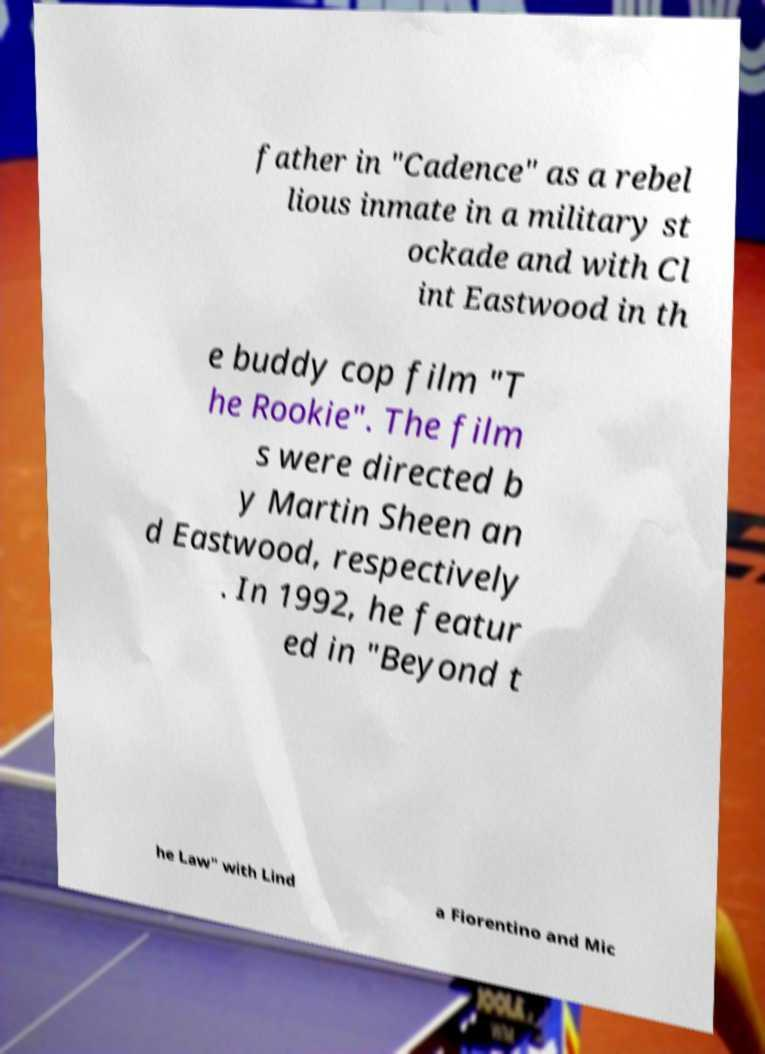Could you assist in decoding the text presented in this image and type it out clearly? father in "Cadence" as a rebel lious inmate in a military st ockade and with Cl int Eastwood in th e buddy cop film "T he Rookie". The film s were directed b y Martin Sheen an d Eastwood, respectively . In 1992, he featur ed in "Beyond t he Law" with Lind a Fiorentino and Mic 